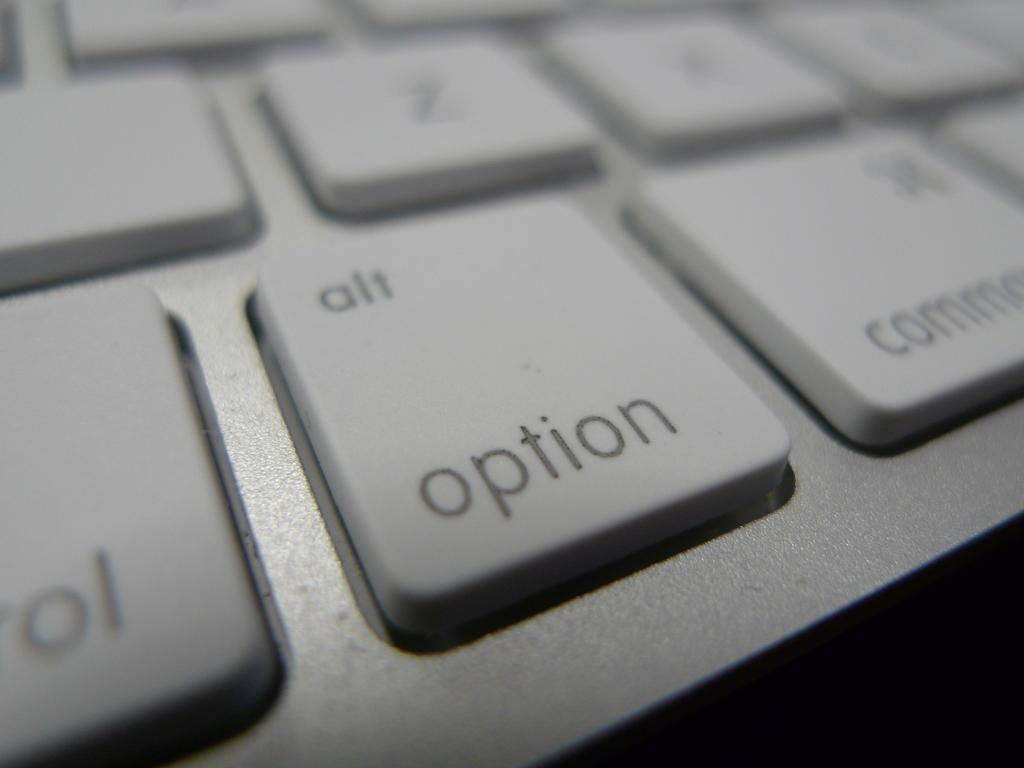Provide a one-sentence caption for the provided image. A white key for the alt option is zoomed in on. 